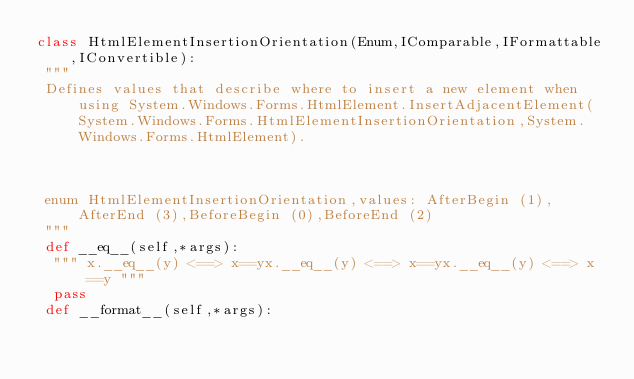Convert code to text. <code><loc_0><loc_0><loc_500><loc_500><_Python_>class HtmlElementInsertionOrientation(Enum,IComparable,IFormattable,IConvertible):
 """
 Defines values that describe where to insert a new element when using System.Windows.Forms.HtmlElement.InsertAdjacentElement(System.Windows.Forms.HtmlElementInsertionOrientation,System.Windows.Forms.HtmlElement).

 

 enum HtmlElementInsertionOrientation,values: AfterBegin (1),AfterEnd (3),BeforeBegin (0),BeforeEnd (2)
 """
 def __eq__(self,*args):
  """ x.__eq__(y) <==> x==yx.__eq__(y) <==> x==yx.__eq__(y) <==> x==y """
  pass
 def __format__(self,*args):</code> 